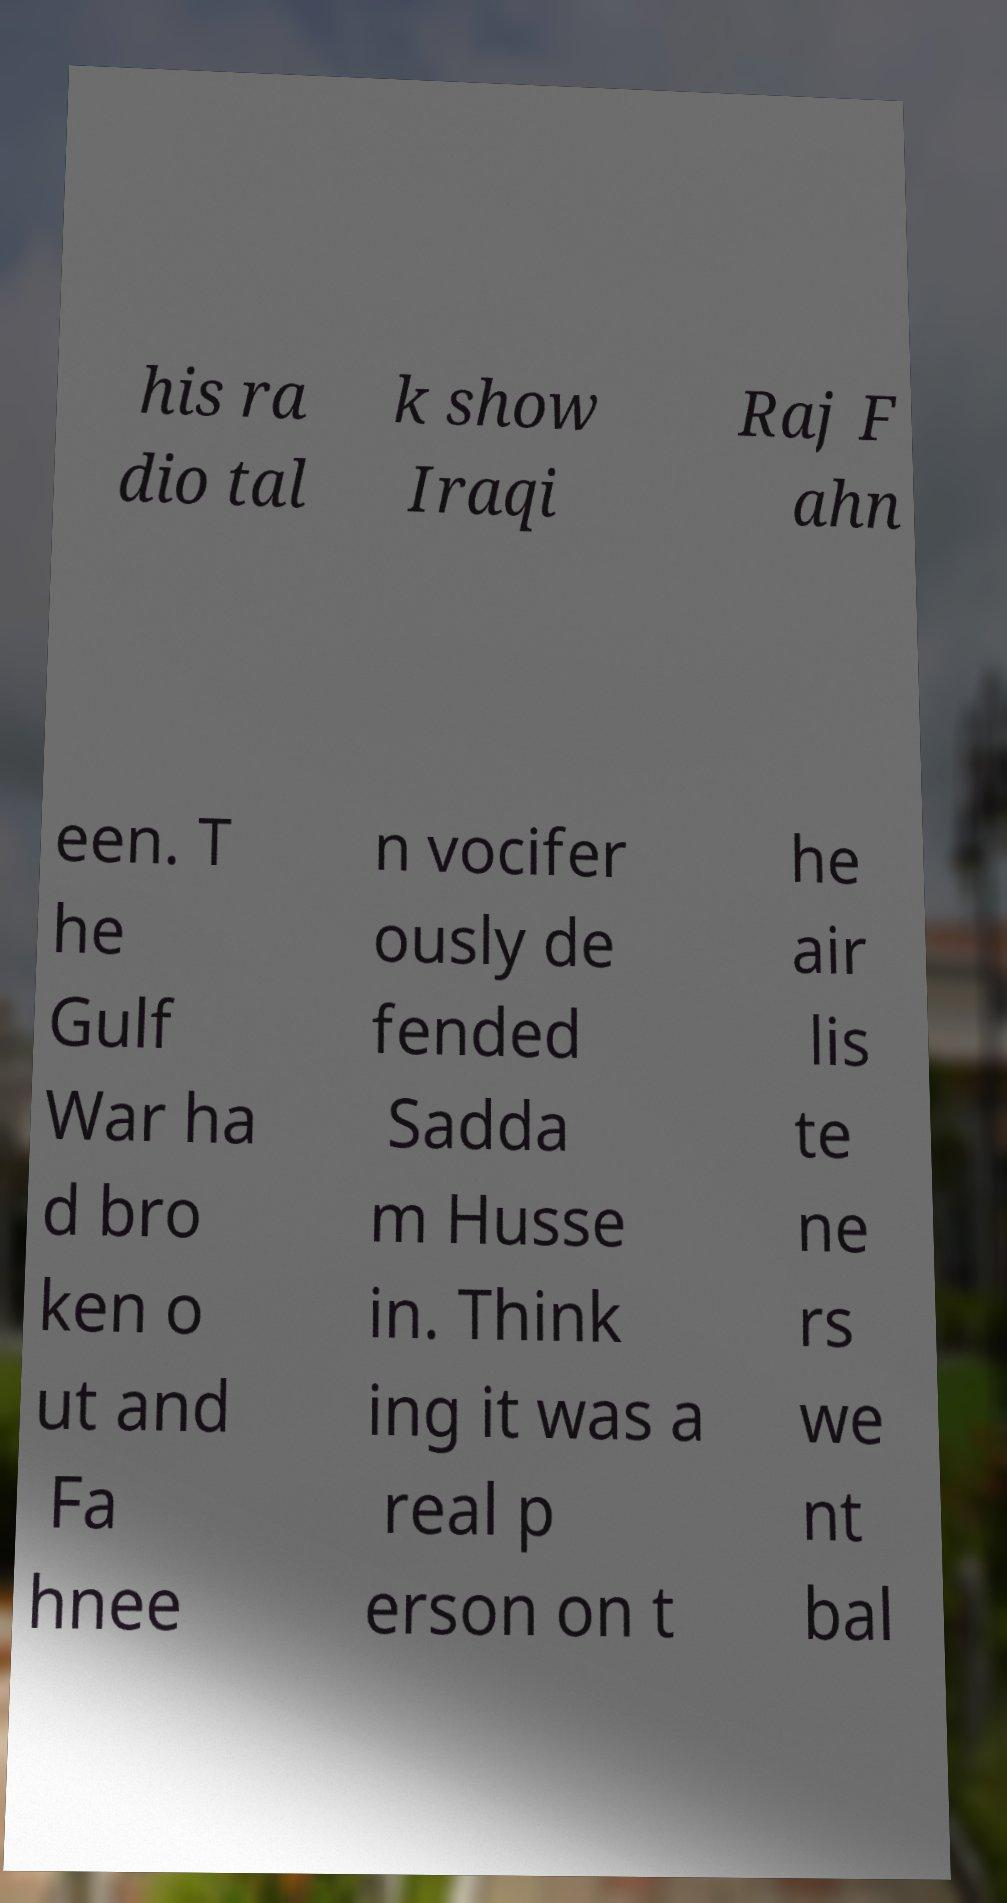Could you extract and type out the text from this image? his ra dio tal k show Iraqi Raj F ahn een. T he Gulf War ha d bro ken o ut and Fa hnee n vocifer ously de fended Sadda m Husse in. Think ing it was a real p erson on t he air lis te ne rs we nt bal 